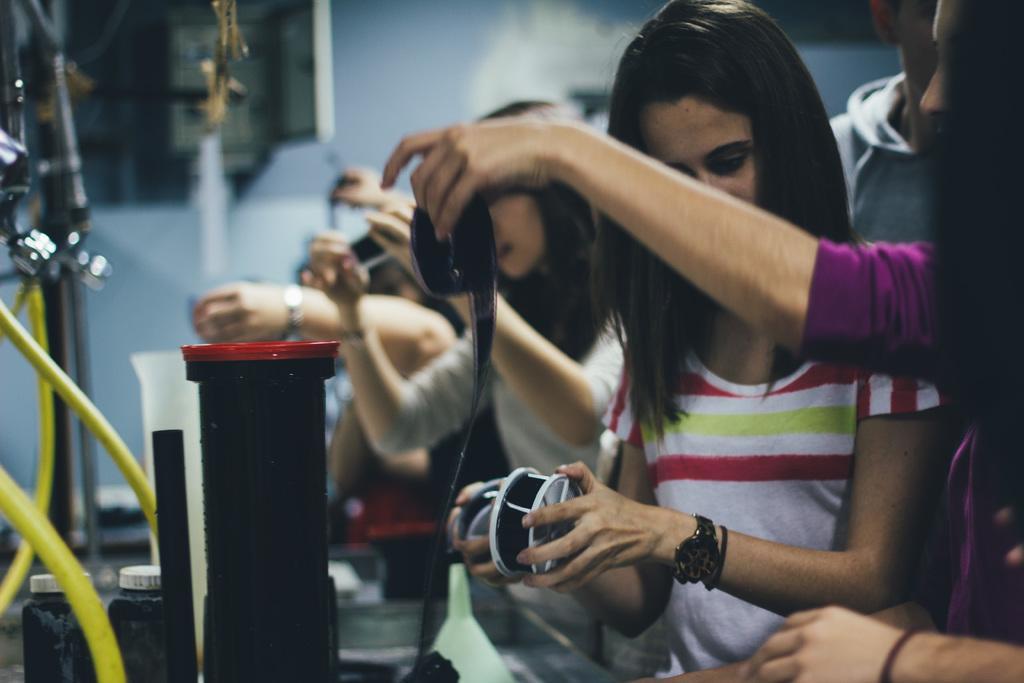How would you summarize this image in a sentence or two? In this image there are group of people standing and holding some objects , there are pipes, bottles, taps, measuring jars, wall. 